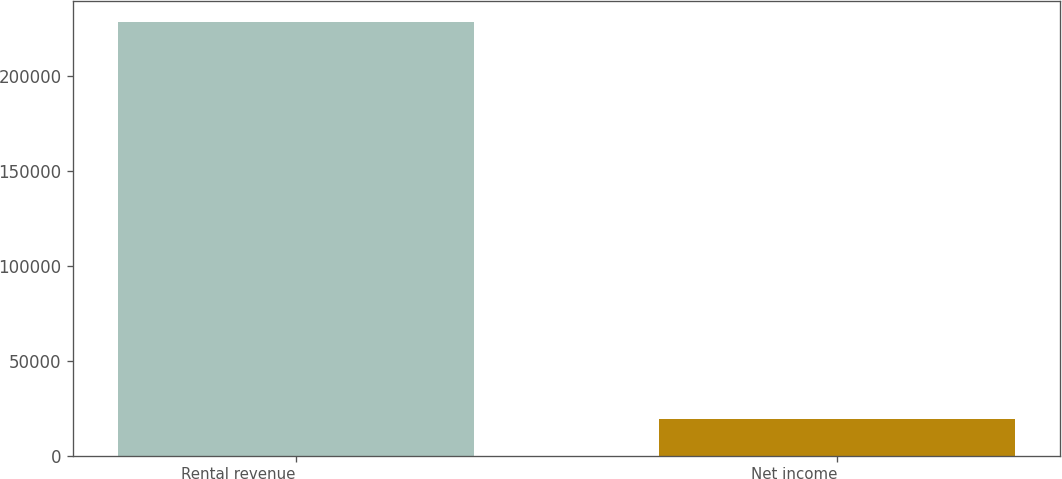Convert chart to OTSL. <chart><loc_0><loc_0><loc_500><loc_500><bar_chart><fcel>Rental revenue<fcel>Net income<nl><fcel>228378<fcel>19202<nl></chart> 